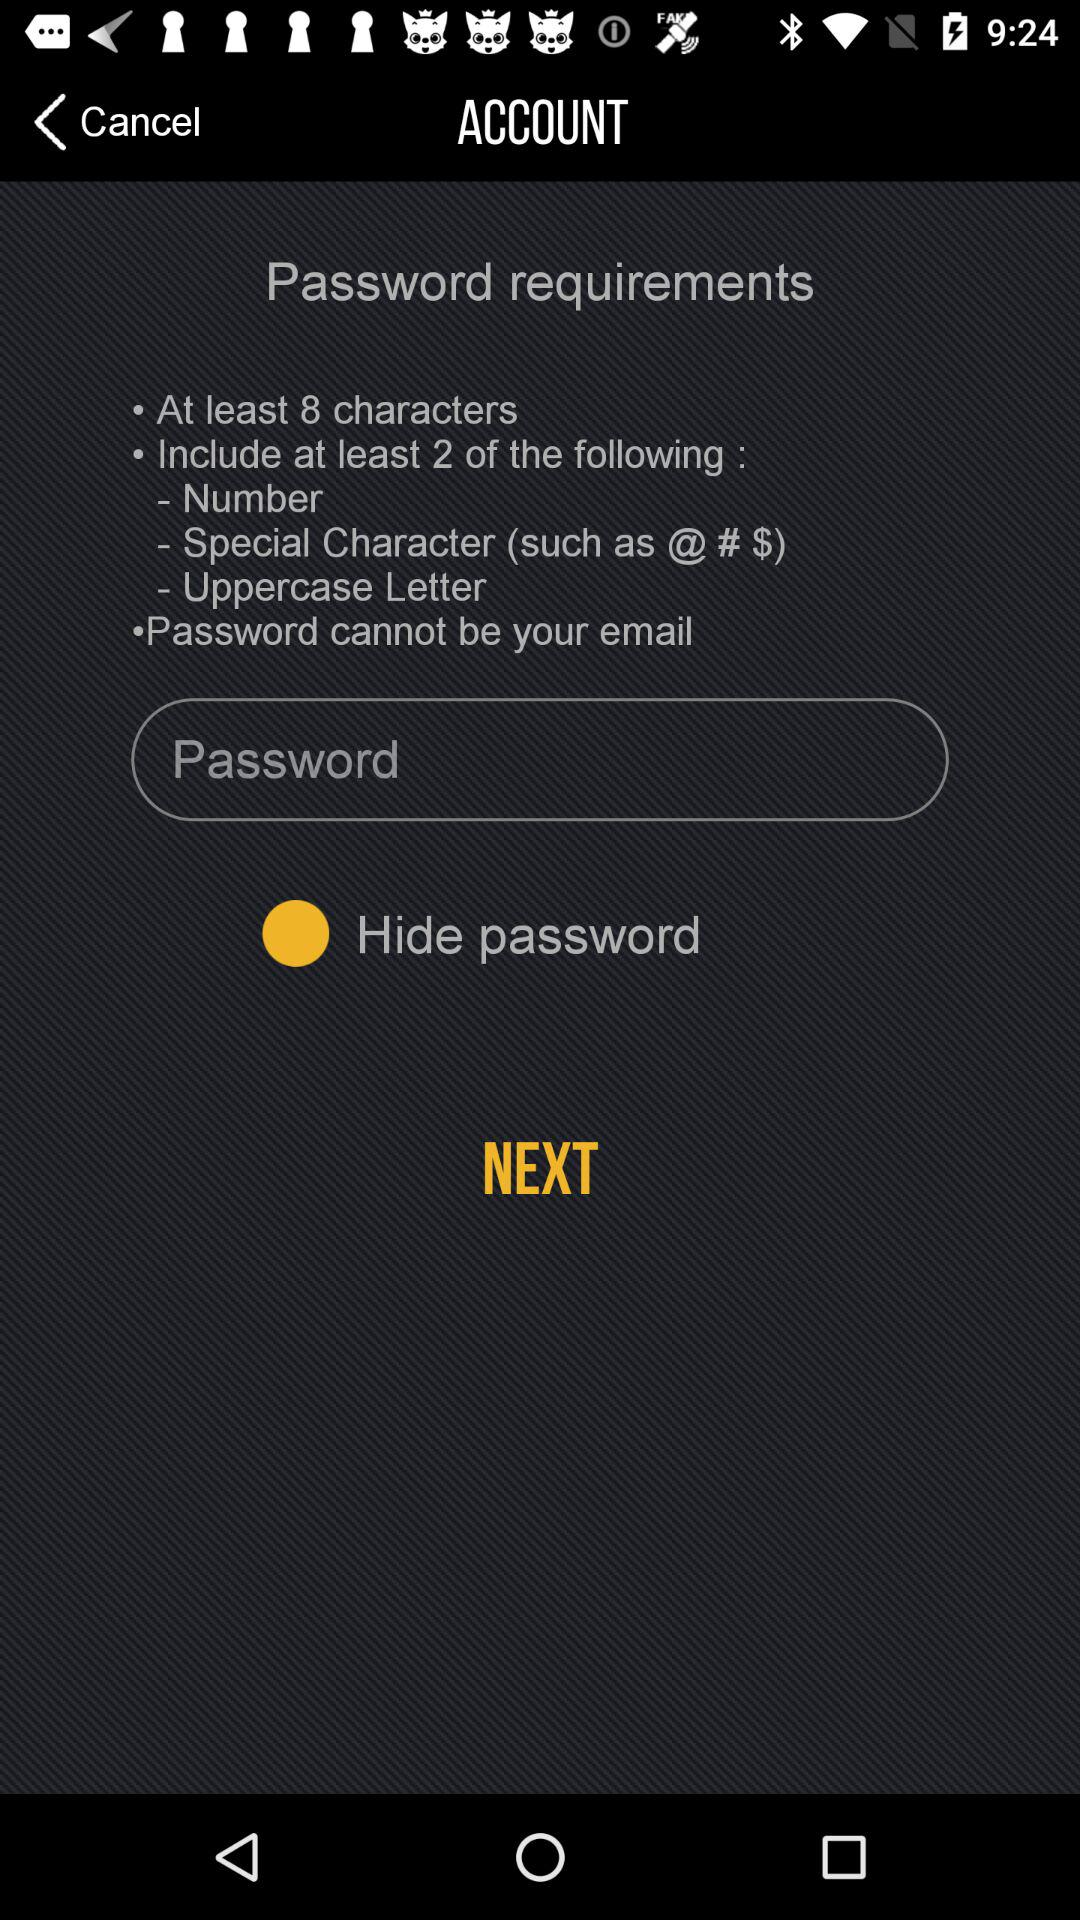What are the special characters available on the screen? The special characters available on the screen are @ # $. 